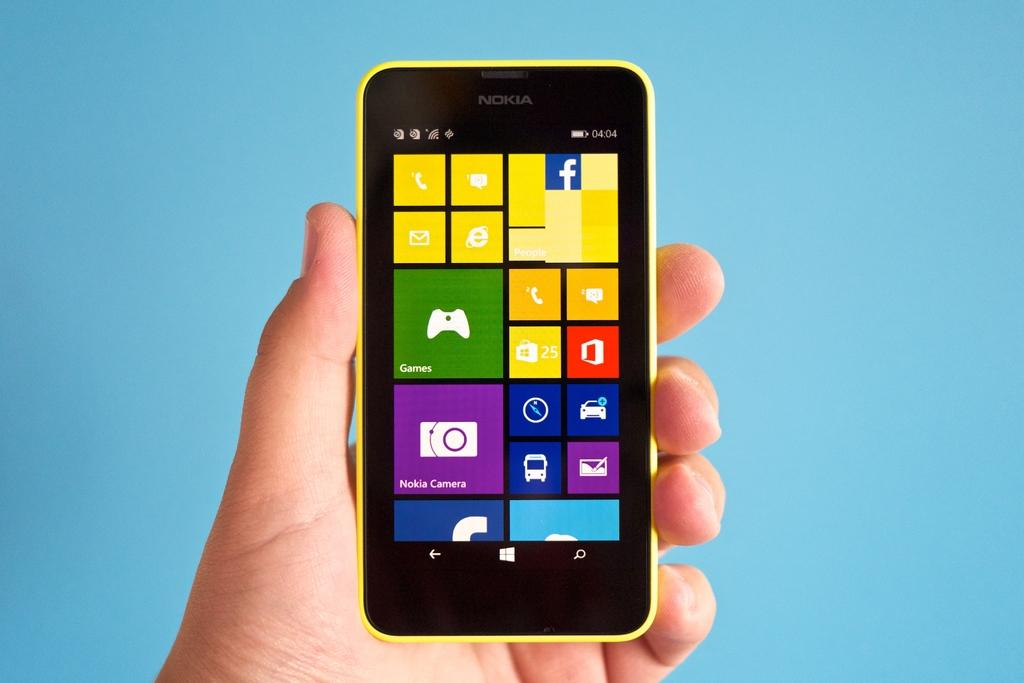<image>
Write a terse but informative summary of the picture. A person is holding a yellow phone that says Nokia. 